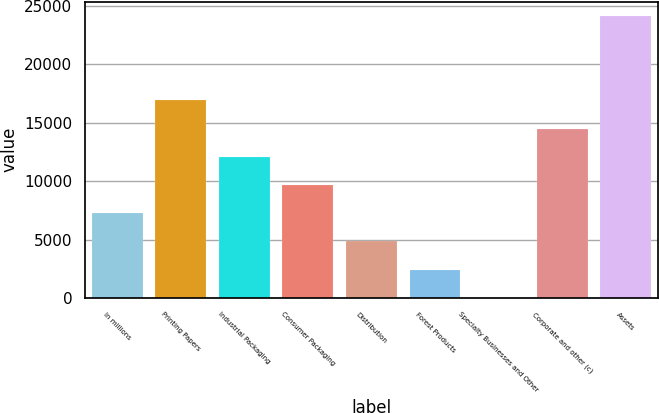Convert chart. <chart><loc_0><loc_0><loc_500><loc_500><bar_chart><fcel>In millions<fcel>Printing Papers<fcel>Industrial Packaging<fcel>Consumer Packaging<fcel>Distribution<fcel>Forest Products<fcel>Specialty Businesses and Other<fcel>Corporate and other (c)<fcel>Assets<nl><fcel>7256.1<fcel>16914.9<fcel>12085.5<fcel>9670.8<fcel>4841.4<fcel>2426.7<fcel>12<fcel>14500.2<fcel>24159<nl></chart> 